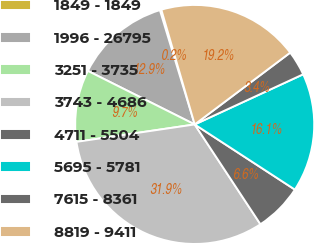Convert chart to OTSL. <chart><loc_0><loc_0><loc_500><loc_500><pie_chart><fcel>1849 - 1849<fcel>1996 - 26795<fcel>3251 - 3735<fcel>3743 - 4686<fcel>4711 - 5504<fcel>5695 - 5781<fcel>7615 - 8361<fcel>8819 - 9411<nl><fcel>0.2%<fcel>12.9%<fcel>9.72%<fcel>31.94%<fcel>6.55%<fcel>16.07%<fcel>3.37%<fcel>19.24%<nl></chart> 